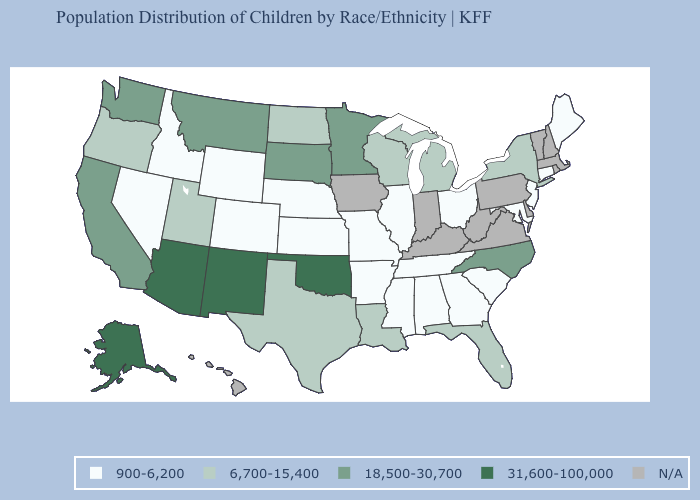Does the map have missing data?
Give a very brief answer. Yes. Among the states that border Idaho , does Nevada have the lowest value?
Be succinct. Yes. Among the states that border Florida , which have the highest value?
Quick response, please. Alabama, Georgia. Name the states that have a value in the range 6,700-15,400?
Short answer required. Florida, Louisiana, Michigan, New York, North Dakota, Oregon, Texas, Utah, Wisconsin. Does North Carolina have the highest value in the USA?
Keep it brief. No. Name the states that have a value in the range 900-6,200?
Concise answer only. Alabama, Arkansas, Colorado, Connecticut, Georgia, Idaho, Illinois, Kansas, Maine, Maryland, Mississippi, Missouri, Nebraska, Nevada, New Jersey, Ohio, South Carolina, Tennessee, Wyoming. Does Louisiana have the lowest value in the South?
Write a very short answer. No. Name the states that have a value in the range 900-6,200?
Concise answer only. Alabama, Arkansas, Colorado, Connecticut, Georgia, Idaho, Illinois, Kansas, Maine, Maryland, Mississippi, Missouri, Nebraska, Nevada, New Jersey, Ohio, South Carolina, Tennessee, Wyoming. Which states have the lowest value in the Northeast?
Give a very brief answer. Connecticut, Maine, New Jersey. Name the states that have a value in the range N/A?
Give a very brief answer. Delaware, Hawaii, Indiana, Iowa, Kentucky, Massachusetts, New Hampshire, Pennsylvania, Rhode Island, Vermont, Virginia, West Virginia. Which states hav the highest value in the South?
Answer briefly. Oklahoma. Name the states that have a value in the range 900-6,200?
Give a very brief answer. Alabama, Arkansas, Colorado, Connecticut, Georgia, Idaho, Illinois, Kansas, Maine, Maryland, Mississippi, Missouri, Nebraska, Nevada, New Jersey, Ohio, South Carolina, Tennessee, Wyoming. Among the states that border Nebraska , does South Dakota have the lowest value?
Be succinct. No. 